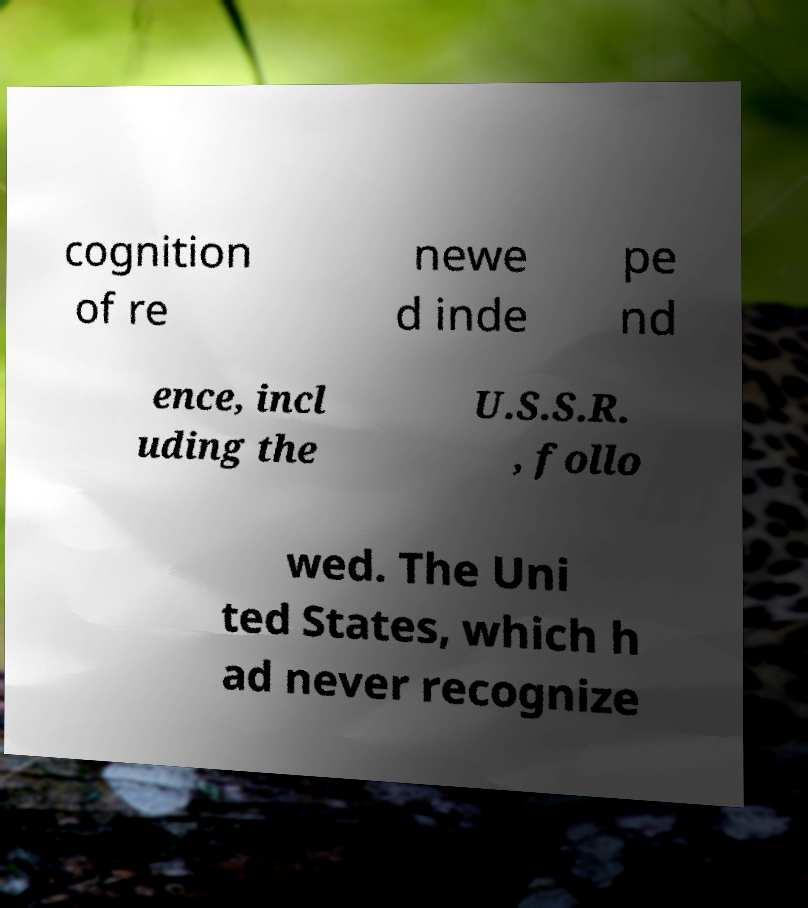Please read and relay the text visible in this image. What does it say? cognition of re newe d inde pe nd ence, incl uding the U.S.S.R. , follo wed. The Uni ted States, which h ad never recognize 